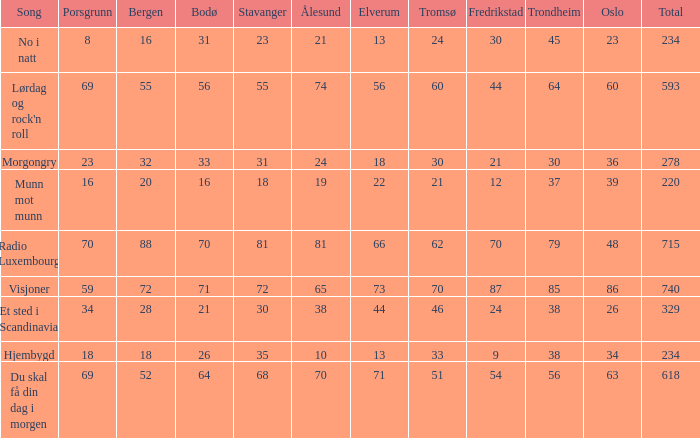What is the lowest total? 220.0. 